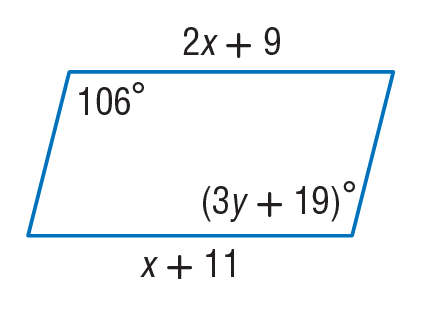Answer the mathemtical geometry problem and directly provide the correct option letter.
Question: Find x so that the quadrilateral is a parallelogram.
Choices: A: 2 B: 4 C: 13 D: 66 A 